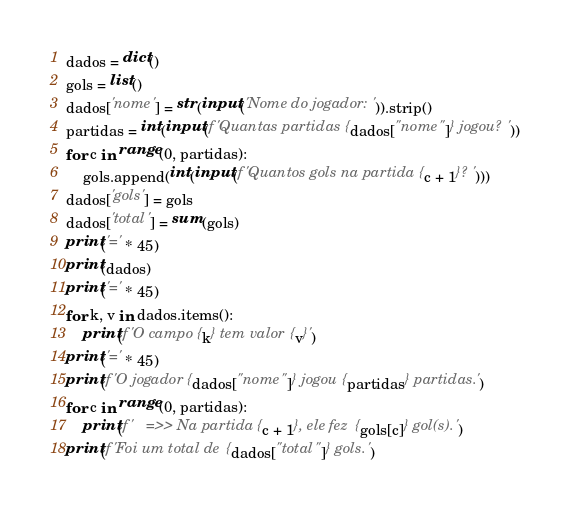Convert code to text. <code><loc_0><loc_0><loc_500><loc_500><_Python_>dados = dict()
gols = list()
dados['nome'] = str(input('Nome do jogador: ')).strip()
partidas = int(input(f'Quantas partidas {dados["nome"]} jogou? '))
for c in range(0, partidas):
    gols.append(int(input(f'Quantos gols na partida {c + 1}? ')))
dados['gols'] = gols
dados['total'] = sum(gols)
print('=' * 45)
print(dados)
print('=' * 45)
for k, v in dados.items():
    print(f'O campo {k} tem valor {v}')
print('=' * 45)
print(f'O jogador {dados["nome"]} jogou {partidas} partidas.')
for c in range(0, partidas):
    print(f'   =>> Na partida {c + 1}, ele fez {gols[c]} gol(s).')
print(f'Foi um total de {dados["total"]} gols.')
</code> 